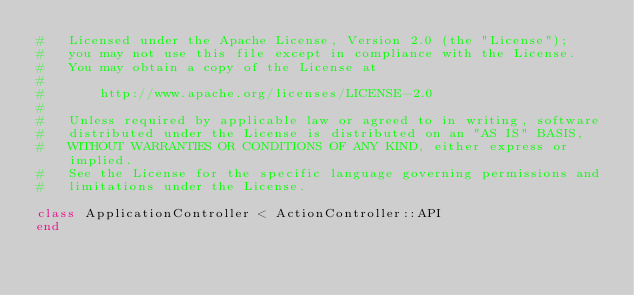<code> <loc_0><loc_0><loc_500><loc_500><_Ruby_>#   Licensed under the Apache License, Version 2.0 (the "License");
#   you may not use this file except in compliance with the License.
#   You may obtain a copy of the License at
# 
#       http://www.apache.org/licenses/LICENSE-2.0
# 
#   Unless required by applicable law or agreed to in writing, software
#   distributed under the License is distributed on an "AS IS" BASIS,
#   WITHOUT WARRANTIES OR CONDITIONS OF ANY KIND, either express or implied.
#   See the License for the specific language governing permissions and
#   limitations under the License.

class ApplicationController < ActionController::API
end
</code> 